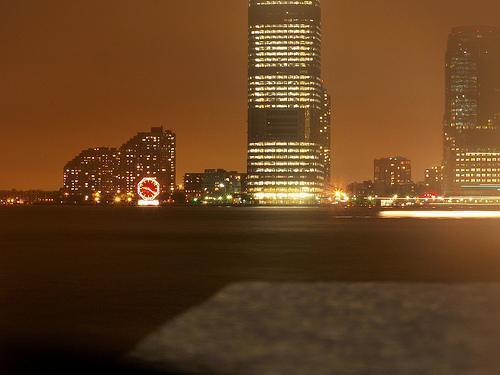How many people are dancing on the top of the building ?
Give a very brief answer. 0. 